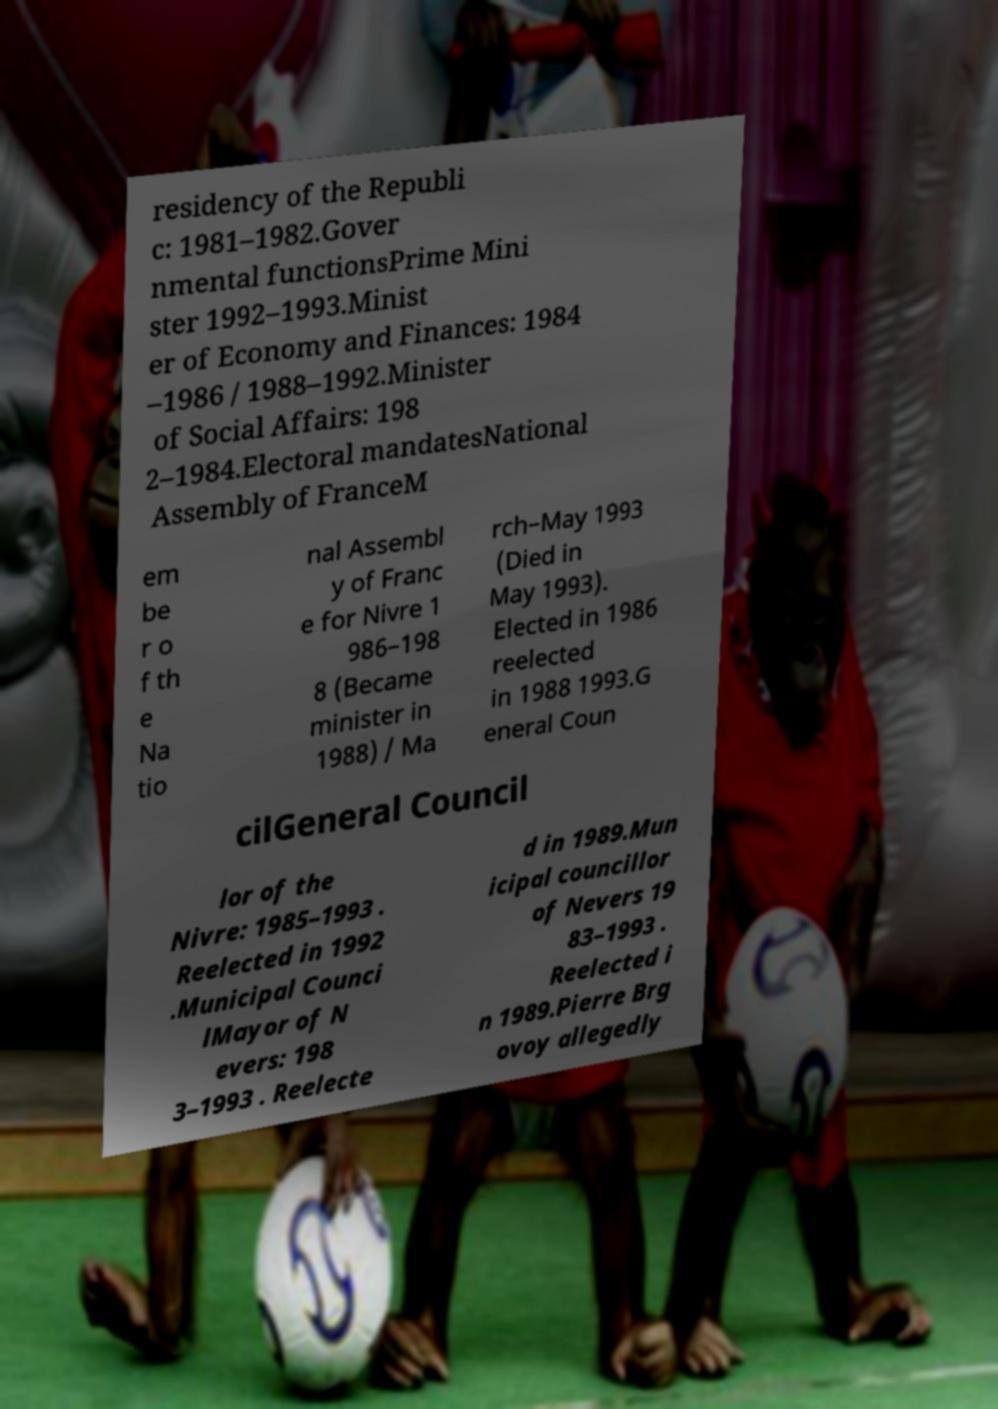Could you extract and type out the text from this image? residency of the Republi c: 1981–1982.Gover nmental functionsPrime Mini ster 1992–1993.Minist er of Economy and Finances: 1984 –1986 / 1988–1992.Minister of Social Affairs: 198 2–1984.Electoral mandatesNational Assembly of FranceM em be r o f th e Na tio nal Assembl y of Franc e for Nivre 1 986–198 8 (Became minister in 1988) / Ma rch–May 1993 (Died in May 1993). Elected in 1986 reelected in 1988 1993.G eneral Coun cilGeneral Council lor of the Nivre: 1985–1993 . Reelected in 1992 .Municipal Counci lMayor of N evers: 198 3–1993 . Reelecte d in 1989.Mun icipal councillor of Nevers 19 83–1993 . Reelected i n 1989.Pierre Brg ovoy allegedly 